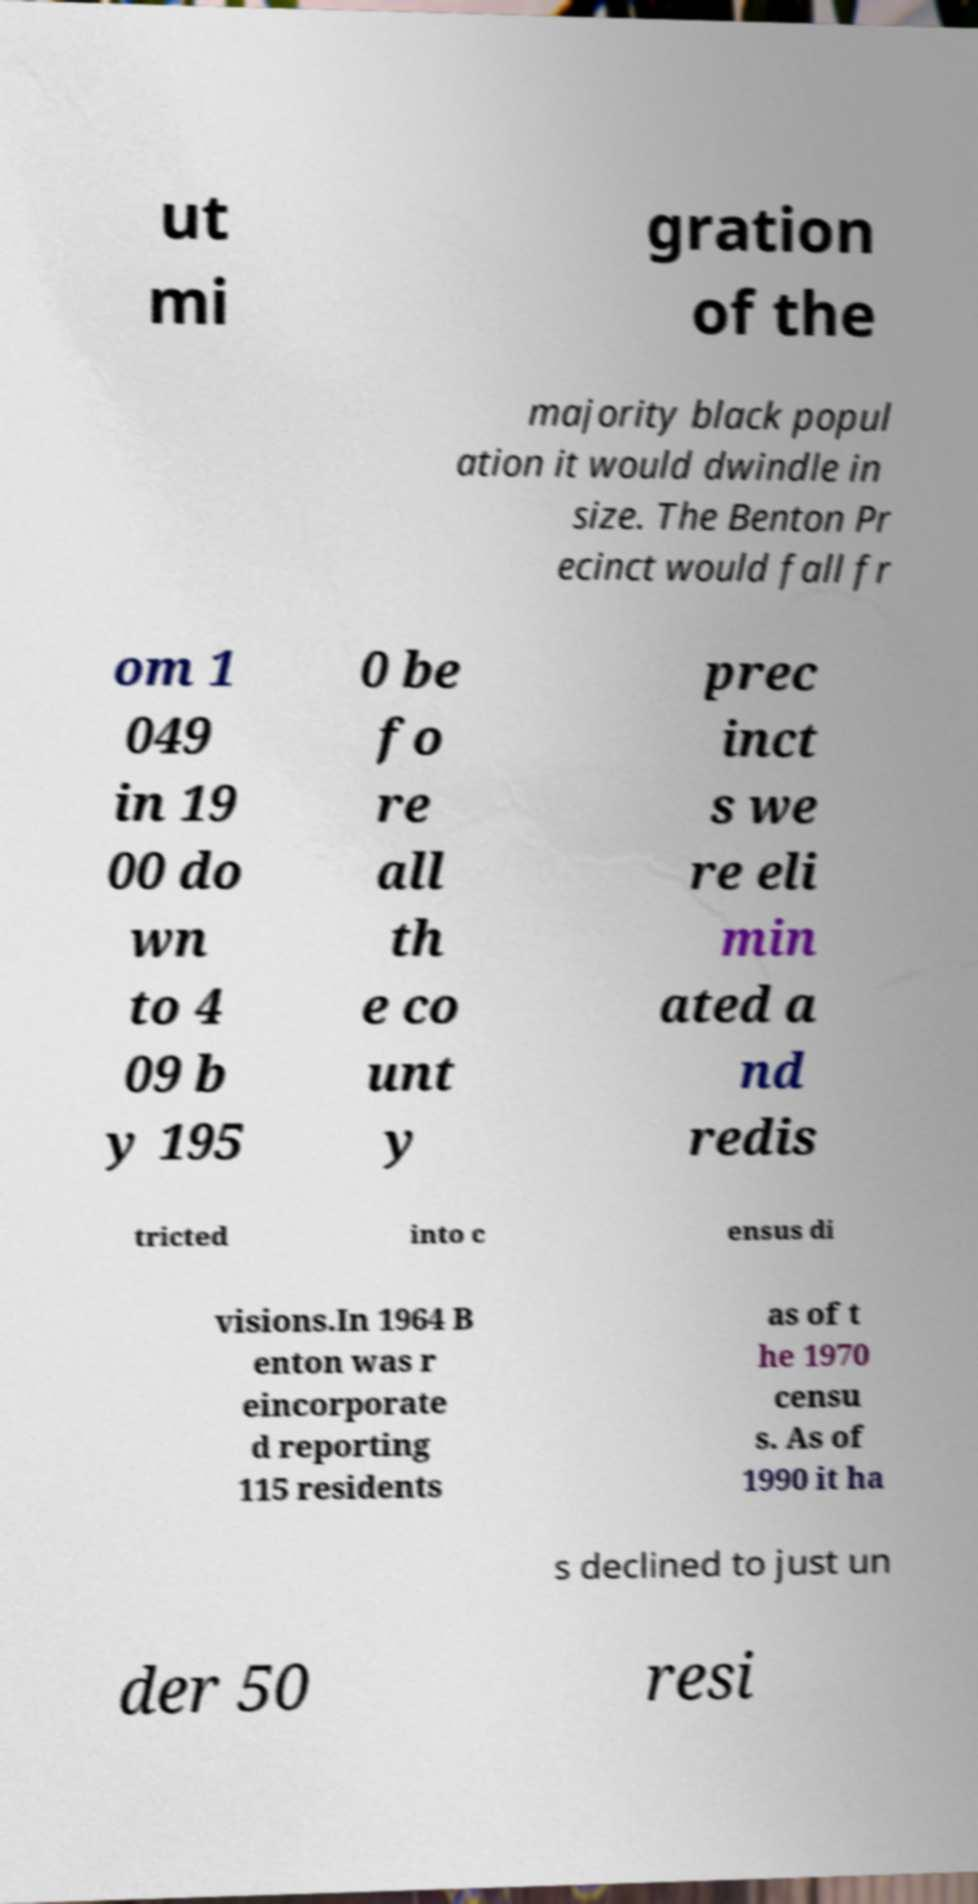Could you assist in decoding the text presented in this image and type it out clearly? ut mi gration of the majority black popul ation it would dwindle in size. The Benton Pr ecinct would fall fr om 1 049 in 19 00 do wn to 4 09 b y 195 0 be fo re all th e co unt y prec inct s we re eli min ated a nd redis tricted into c ensus di visions.In 1964 B enton was r eincorporate d reporting 115 residents as of t he 1970 censu s. As of 1990 it ha s declined to just un der 50 resi 